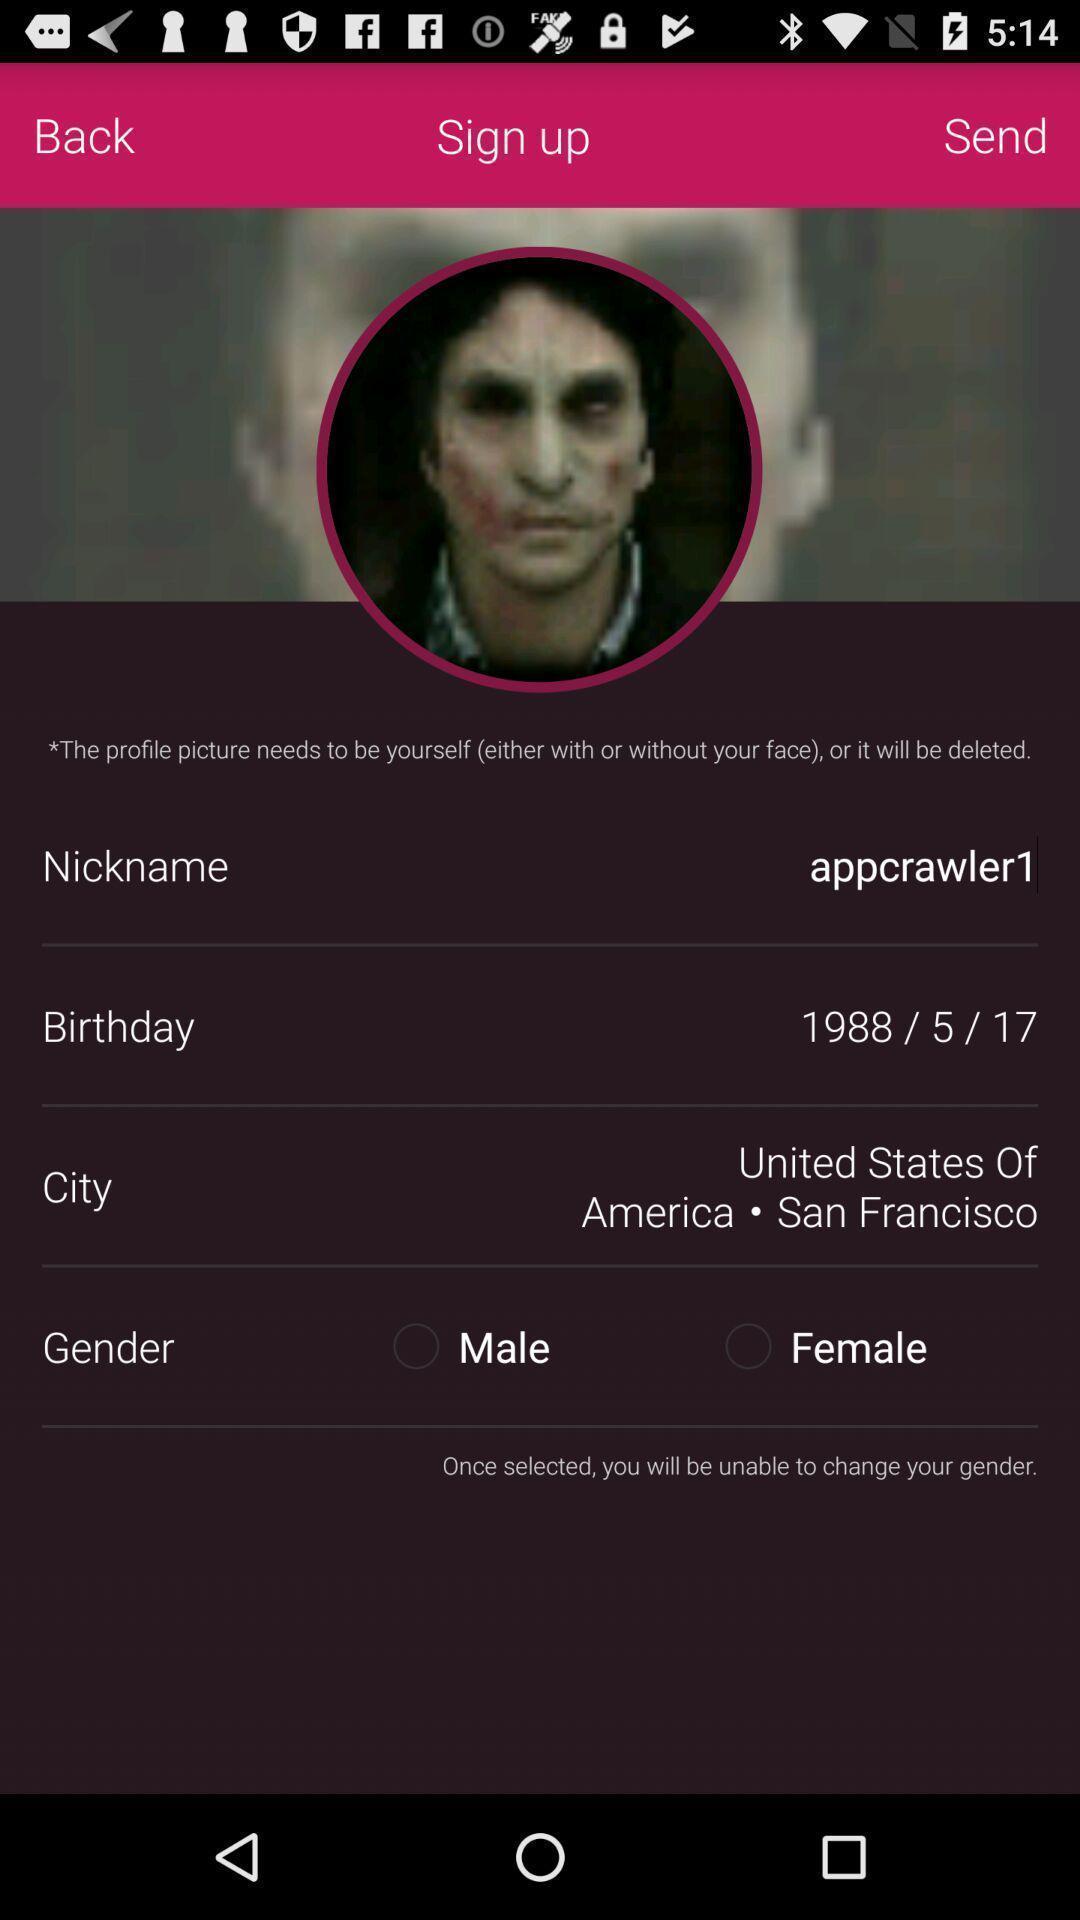Describe the key features of this screenshot. Sign-in page of dating app. 